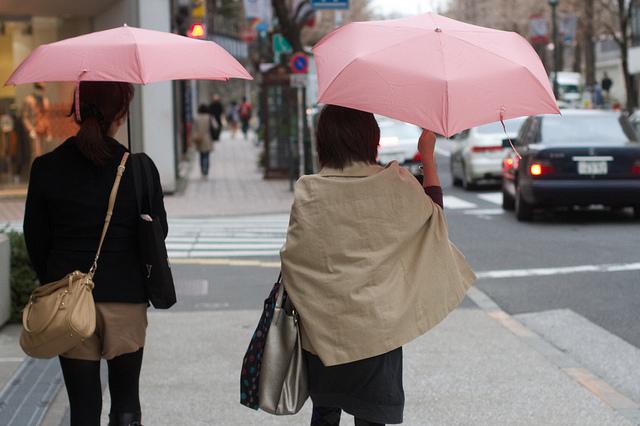Is the woman on the right wearing her jacket properly?
Be succinct. No. Are these both women?
Quick response, please. Yes. Are the both people holding a umbrella?
Write a very short answer. Yes. 